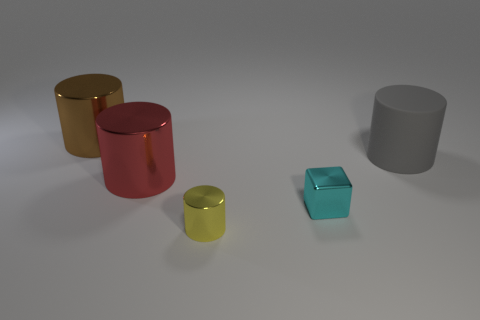Subtract all red metal cylinders. How many cylinders are left? 3 Subtract all gray cylinders. How many cylinders are left? 3 Subtract 0 purple cubes. How many objects are left? 5 Subtract all blocks. How many objects are left? 4 Subtract 1 blocks. How many blocks are left? 0 Subtract all blue cylinders. Subtract all green balls. How many cylinders are left? 4 Subtract all purple cylinders. How many gray cubes are left? 0 Subtract all small yellow metallic cylinders. Subtract all gray shiny cubes. How many objects are left? 4 Add 2 shiny cylinders. How many shiny cylinders are left? 5 Add 2 tiny shiny cubes. How many tiny shiny cubes exist? 3 